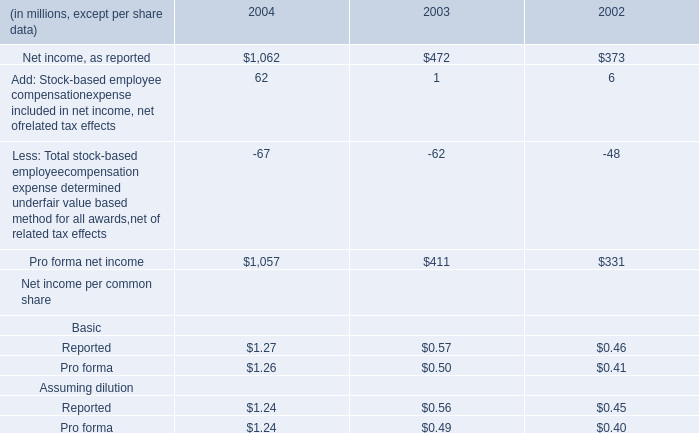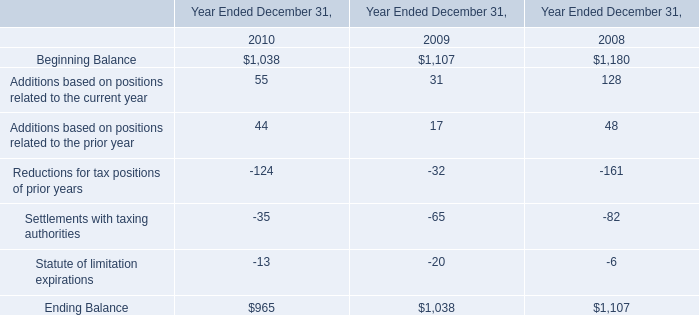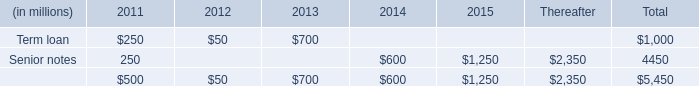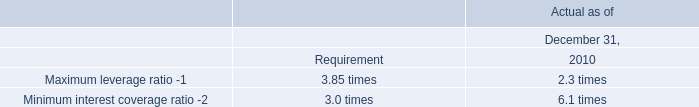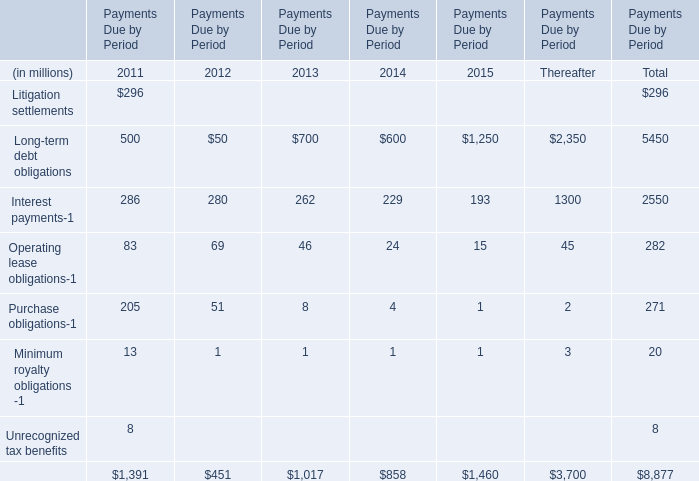what's the total amount of Senior notes of Thereafter, and Ending Balance of Year Ended December 31, 2008 ? 
Computations: (2350.0 + 1107.0)
Answer: 3457.0. 